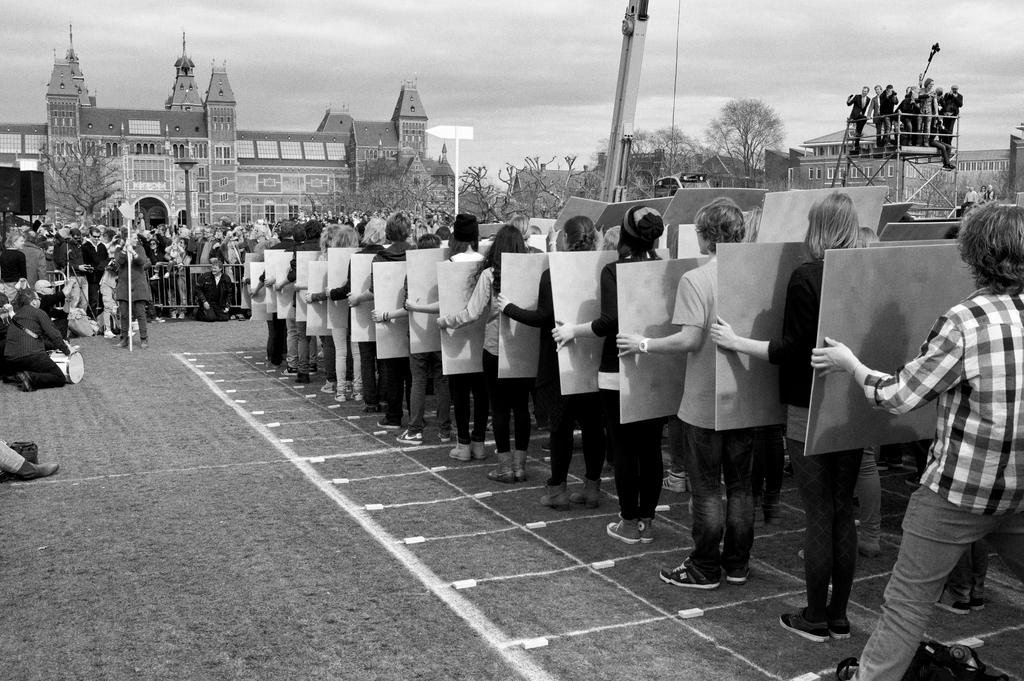What are the persons in the image holding in their hands? The persons in the image are holding an object in their hands. What can be seen in front of the persons holding the object? There are other people standing in front of them. What is visible in the background of the image? There are buildings and trees in the background of the image. What type of key can be seen in the nest in the image? There is no key or nest present in the image. 